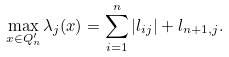Convert formula to latex. <formula><loc_0><loc_0><loc_500><loc_500>\max _ { x \in Q _ { n } ^ { \prime } } \lambda _ { j } ( x ) = \sum _ { i = 1 } ^ { n } | l _ { i j } | + l _ { n + 1 , j } .</formula> 